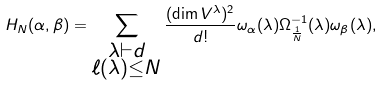Convert formula to latex. <formula><loc_0><loc_0><loc_500><loc_500>H _ { N } ( \alpha , \beta ) = \sum _ { \substack { \lambda \vdash d \\ \ell ( \lambda ) \leq N } } \frac { ( \dim V ^ { \lambda } ) ^ { 2 } } { d ! } \omega _ { \alpha } ( \lambda ) \Omega _ { \frac { 1 } { N } } ^ { - 1 } ( \lambda ) \omega _ { \beta } ( \lambda ) ,</formula> 